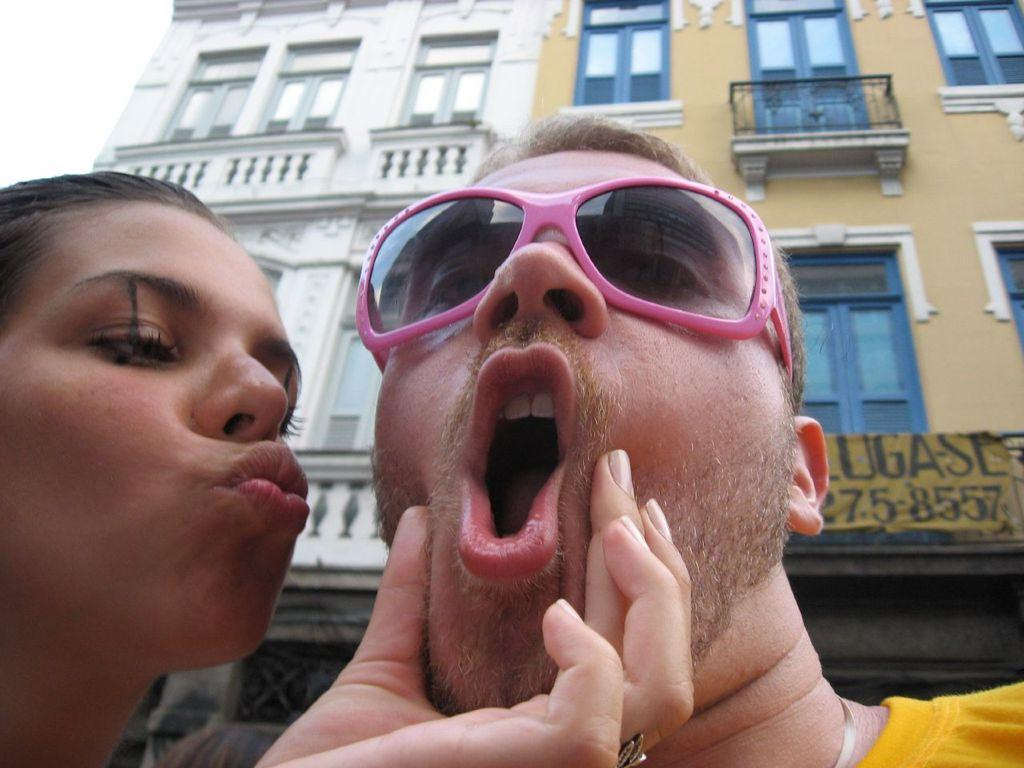How many people are in the foreground of the image? There are two persons in the foreground of the image. What can be seen in the background of the image? There is a building in the background of the image. What is visible at the top of the image? The sky is visible at the top of the image. What is the name of the hole in the image? There is no hole present in the image. 